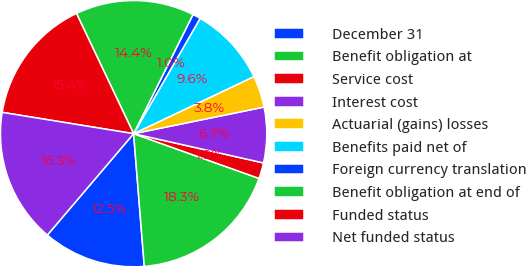Convert chart to OTSL. <chart><loc_0><loc_0><loc_500><loc_500><pie_chart><fcel>December 31<fcel>Benefit obligation at<fcel>Service cost<fcel>Interest cost<fcel>Actuarial (gains) losses<fcel>Benefits paid net of<fcel>Foreign currency translation<fcel>Benefit obligation at end of<fcel>Funded status<fcel>Net funded status<nl><fcel>12.5%<fcel>18.27%<fcel>1.93%<fcel>6.73%<fcel>3.85%<fcel>9.62%<fcel>0.97%<fcel>14.42%<fcel>15.38%<fcel>16.34%<nl></chart> 